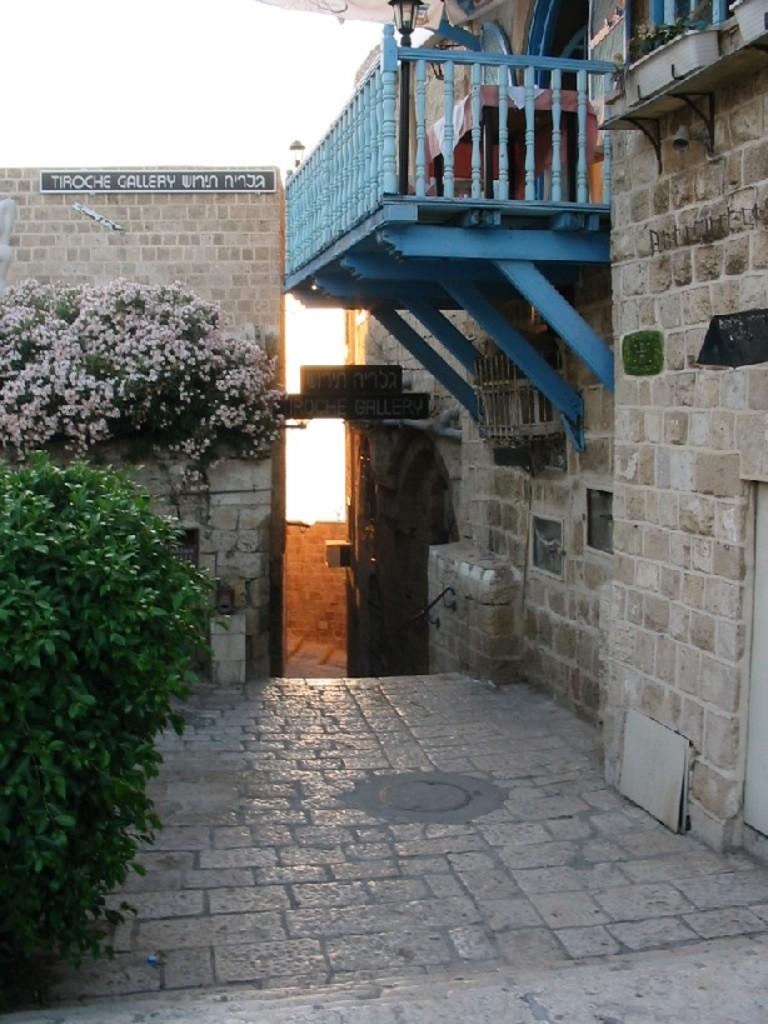What type of vegetation is on the left side of the image? There are plants and flowers on the left side of the image. What is behind the plants in the image? There is a wall behind the plants. What structure is located on the right side of the image? There is a building on the right side of the image. How many apples are hanging from the wall in the image? There are no apples present in the image; it features plants and flowers on the left side and a building on the right side. What type of iron is used to support the plants in the image? There is no iron visible in the image; it only shows plants, flowers, a wall, and a building. 